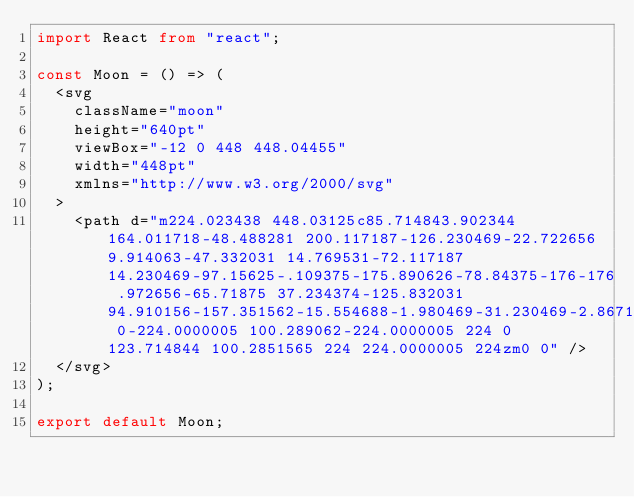<code> <loc_0><loc_0><loc_500><loc_500><_TypeScript_>import React from "react";

const Moon = () => (
  <svg
    className="moon"
    height="640pt"
    viewBox="-12 0 448 448.04455"
    width="448pt"
    xmlns="http://www.w3.org/2000/svg"
  >
    <path d="m224.023438 448.03125c85.714843.902344 164.011718-48.488281 200.117187-126.230469-22.722656 9.914063-47.332031 14.769531-72.117187 14.230469-97.15625-.109375-175.890626-78.84375-176-176 .972656-65.71875 37.234374-125.832031 94.910156-157.351562-15.554688-1.980469-31.230469-2.867188-46.910156-2.648438-123.714844 0-224.0000005 100.289062-224.0000005 224 0 123.714844 100.2851565 224 224.0000005 224zm0 0" />
  </svg>
);

export default Moon;
</code> 